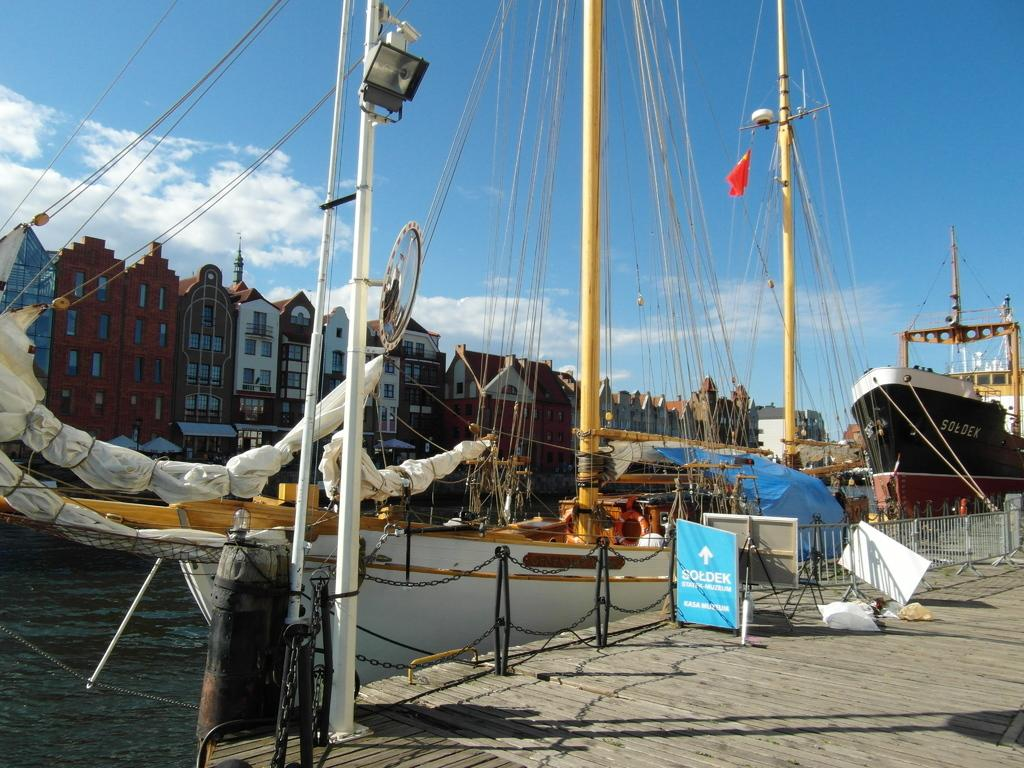What is located in the center of the image? There are buildings in the center of the image. What is at the bottom of the image? There is water at the bottom of the image. What is floating on the water? Ships are visible on the water. What objects can be seen in the image besides the buildings and ships? There are boards and ropes in the image. What can be seen in the background of the image? The sky is visible in the background of the image. What type of protest is happening in the image? There is no protest present in the image; it features buildings, water, ships, boards, ropes, and the sky. Who is the servant attending to in the image? There is no servant present in the image. 